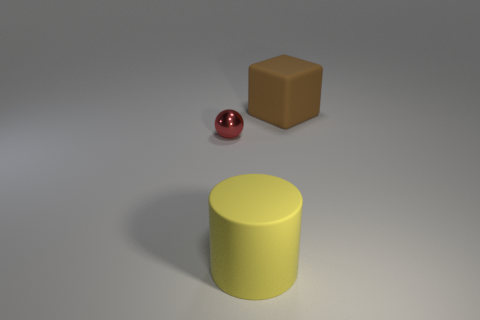What shape is the object that is the same size as the brown rubber block?
Offer a terse response. Cylinder. Is there a big object of the same color as the block?
Ensure brevity in your answer.  No. Is the number of big things in front of the red metallic object the same as the number of red balls?
Offer a terse response. Yes. Does the matte cylinder have the same color as the small metal thing?
Give a very brief answer. No. There is a object that is on the right side of the tiny metal sphere and behind the big yellow thing; how big is it?
Make the answer very short. Large. There is a large cylinder that is made of the same material as the brown object; what color is it?
Make the answer very short. Yellow. What number of brown objects have the same material as the block?
Make the answer very short. 0. Are there the same number of large yellow cylinders on the left side of the yellow cylinder and matte things that are to the left of the small red metallic ball?
Provide a short and direct response. Yes. There is a large yellow thing; is its shape the same as the large rubber object that is behind the red object?
Your response must be concise. No. Is there anything else that is the same shape as the small object?
Keep it short and to the point. No. 